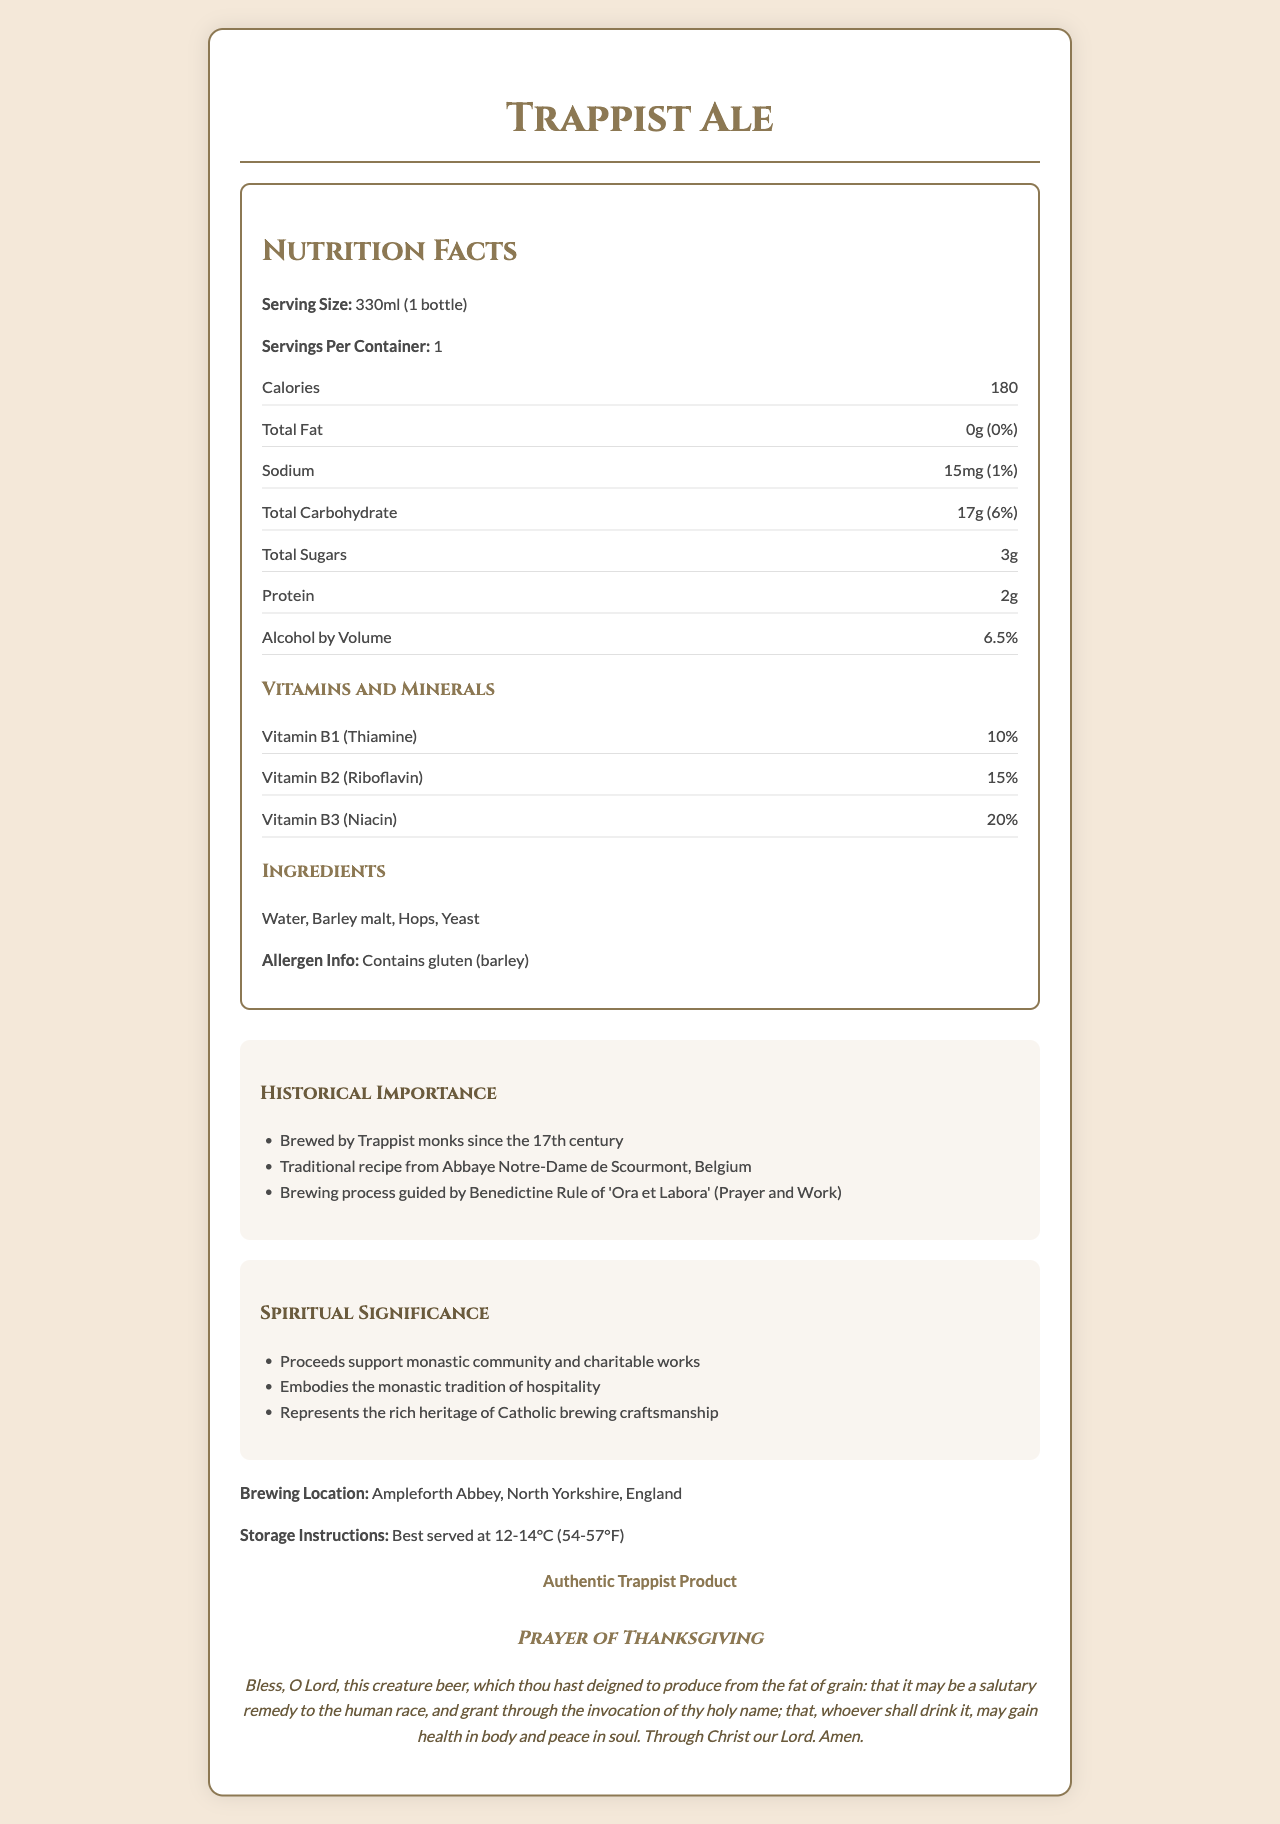what is the serving size of Trappist Ale? The serving size is clearly mentioned in the document under the nutrition facts section.
Answer: 330ml (1 bottle) how many calories are in one serving of Trappist Ale? The document states that each serving contains 180 calories.
Answer: 180 what is the percentage of daily value of Vitamin B2 provided by Trappist Ale? The daily value for Vitamin B2 (Riboflavin) is listed as 15%.
Answer: 15% which brewing location is mentioned in the document? The brewing location is specified as Ampleforth Abbey, North Yorkshire, England.
Answer: Ampleforth Abbey, North Yorkshire, England what are the ingredients of Trappist Ale? The document lists the ingredients as Water, Barley malt, Hops, and Yeast.
Answer: Water, Barley malt, Hops, Yeast which of the following is not a historical fact about Trappist Ale? A. Brewed by Trappist monks since the 17th century B. Uses a recipe from a French monastery C. Traditional recipe from Abbaye Notre-Dame de Scourmont, Belgium D. Brewing process guided by Benedictine Rule of 'Ora et Labora' (Prayer and Work) The historical facts provided mention Belgium, not a French monastery.
Answer: B what is the certification status of Trappist Ale? A. Non-Certified B. Certified Authentic Ale C. Authentic Trappist Product The document certifies Trappist Ale as an "Authentic Trappist Product."
Answer: C is Trappist Ale gluten-free? The allergen information in the document indicates that it contains gluten (barley).
Answer: No describe the main idea of the document. The main idea of the document centers around presenting comprehensive information about Trappist Ale, highlighting its nutritional profile, religious and historical context, and its production specifics.
Answer: The document provides detailed nutrition facts, historical importance, spiritual significance, ingredients, allergen information, and brewing location of Trappist Ale, a beer brewed by Trappist monks. It includes a certification marking it as an authentic Trappist product and a prayer of thanksgiving. does the document specify the exact amount of alcohol Trappist Ale contains? The document does not specify the exact amount of alcohol; it only gives the alcohol by volume (ABV) as 6.5%.
Answer: No what are the proceeds from Trappist Ale used for? Under the spiritual significance section, the document mentions that proceeds support the monastic community and charitable works.
Answer: Support monastic community and charitable works how should Trappist Ale be stored? The document provides storage instructions stating that the ale is best served at 12-14°C (54-57°F).
Answer: Best served at 12-14°C (54-57°F) explain the vitamins found in Trappist Ale and their daily values. The vitamins and their daily values are listed in the nutrition facts section.
Answer: Trappist Ale contains Vitamin B1 (Thiamine) at 10% daily value, Vitamin B2 (Riboflavin) at 15% daily value, and Vitamin B3 (Niacin) at 20% daily value. who is responsible for brewing Trappist Ale, according to the document? The historical importance section notes that Trappist Ale has been brewed by Trappist monks since the 17th century.
Answer: Trappist monks 